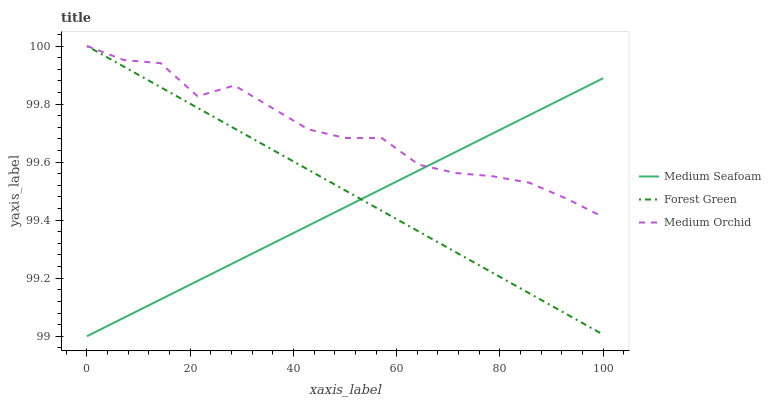Does Medium Seafoam have the minimum area under the curve?
Answer yes or no. Yes. Does Medium Orchid have the maximum area under the curve?
Answer yes or no. Yes. Does Medium Orchid have the minimum area under the curve?
Answer yes or no. No. Does Medium Seafoam have the maximum area under the curve?
Answer yes or no. No. Is Forest Green the smoothest?
Answer yes or no. Yes. Is Medium Orchid the roughest?
Answer yes or no. Yes. Is Medium Seafoam the smoothest?
Answer yes or no. No. Is Medium Seafoam the roughest?
Answer yes or no. No. Does Medium Seafoam have the lowest value?
Answer yes or no. Yes. Does Medium Orchid have the lowest value?
Answer yes or no. No. Does Medium Orchid have the highest value?
Answer yes or no. Yes. Does Medium Seafoam have the highest value?
Answer yes or no. No. Does Medium Seafoam intersect Medium Orchid?
Answer yes or no. Yes. Is Medium Seafoam less than Medium Orchid?
Answer yes or no. No. Is Medium Seafoam greater than Medium Orchid?
Answer yes or no. No. 